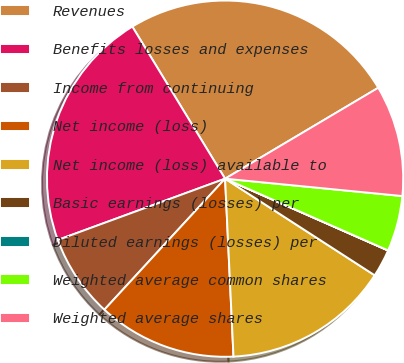Convert chart. <chart><loc_0><loc_0><loc_500><loc_500><pie_chart><fcel>Revenues<fcel>Benefits losses and expenses<fcel>Income from continuing<fcel>Net income (loss)<fcel>Net income (loss) available to<fcel>Basic earnings (losses) per<fcel>Diluted earnings (losses) per<fcel>Weighted average common shares<fcel>Weighted average shares<nl><fcel>25.19%<fcel>21.87%<fcel>7.56%<fcel>12.6%<fcel>15.12%<fcel>2.52%<fcel>0.01%<fcel>5.04%<fcel>10.08%<nl></chart> 